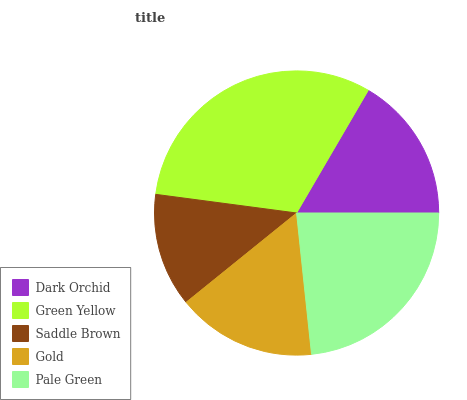Is Saddle Brown the minimum?
Answer yes or no. Yes. Is Green Yellow the maximum?
Answer yes or no. Yes. Is Green Yellow the minimum?
Answer yes or no. No. Is Saddle Brown the maximum?
Answer yes or no. No. Is Green Yellow greater than Saddle Brown?
Answer yes or no. Yes. Is Saddle Brown less than Green Yellow?
Answer yes or no. Yes. Is Saddle Brown greater than Green Yellow?
Answer yes or no. No. Is Green Yellow less than Saddle Brown?
Answer yes or no. No. Is Dark Orchid the high median?
Answer yes or no. Yes. Is Dark Orchid the low median?
Answer yes or no. Yes. Is Saddle Brown the high median?
Answer yes or no. No. Is Saddle Brown the low median?
Answer yes or no. No. 